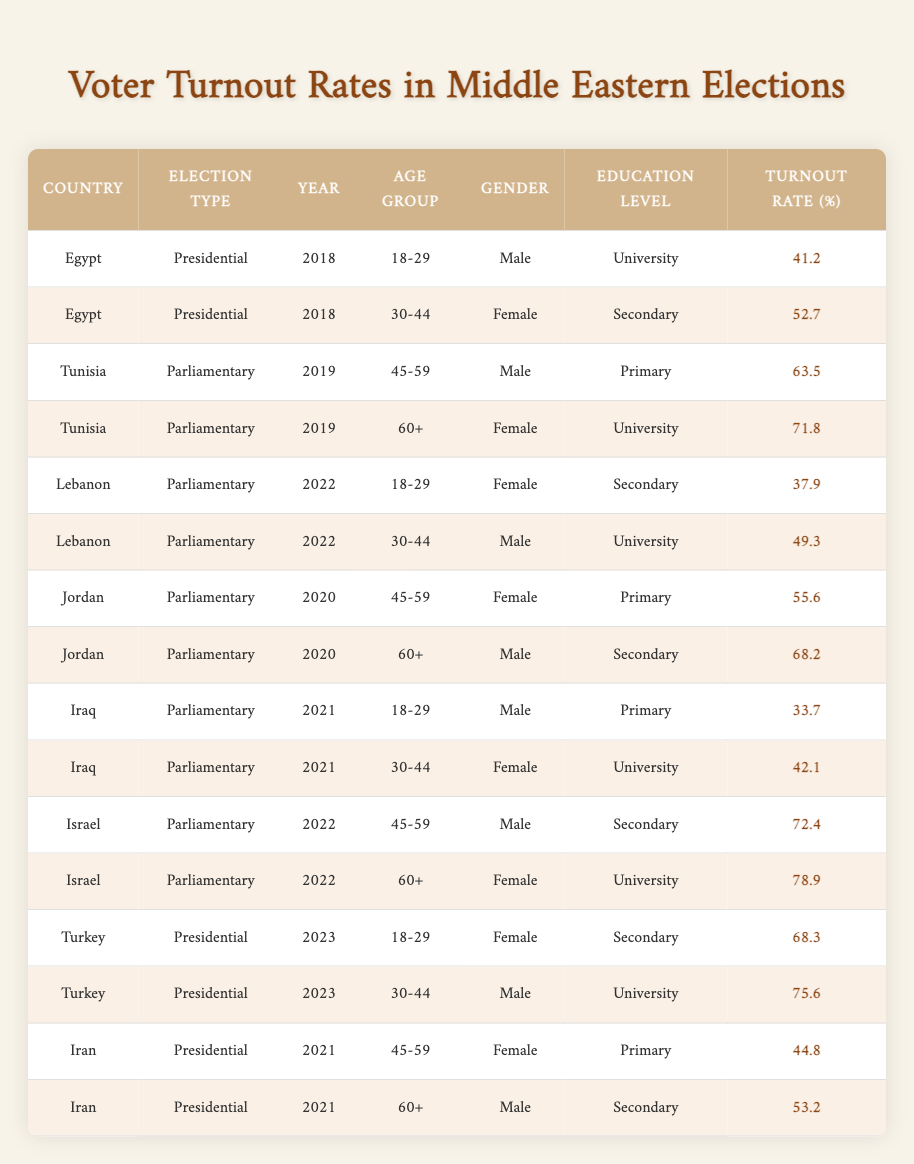What is the highest voter turnout rate reported in the table? By examining the turnout rates in the last column, we can identify that the highest value is 78.9%. It corresponds to the female demographic aged 60+ in Israel during the 2022 parliamentary elections.
Answer: 78.9 What demographic had the lowest voter turnout in Egypt during the 2018 Presidential elections? In the 2018 Presidential elections, the table shows two demographic groups in Egypt: males aged 18-29 with a turnout of 41.2%, and females aged 30-44 with a turnout of 52.7%. Thus, the lowest turnout is for males aged 18-29.
Answer: Males aged 18-29 What was the average voter turnout rate for parliamentary elections across all countries in 2022? The parliamentary elections in 2022 had two records from Lebanon and two from Israel: Lebanon - females aged 18-29 (37.9%) and males aged 30-44 (49.3%); Israel - males aged 45-59 (72.4%) and females aged 60+ (78.9%). Summing these values gives 37.9 + 49.3 + 72.4 + 78.9 = 238.5, and dividing by 4 gives an average turnout of 59.625%.
Answer: 59.63 Is there any instance of a turnout rate below 40% for males aged 18-29? Yes, in the table, we can see that in Iraq for the 2021 parliamentary elections, males aged 18-29 had a turnout rate of 33.7%, which is below 40%.
Answer: Yes Which country had the highest turnout for 30-44 year-old males in presidential elections? Looking specifically at presidential elections, we only see data from Egypt in 2018 and Turkey in 2023. For Egypt (30-44 year-old females), the turnout was 52.7%, whereas Turkey (30-44 year-old males) had a turnout of 75.6%. Thus, Turkey has the higher turnout.
Answer: Turkey What is the difference in voter turnout percentage between the oldest age group (60+) for females in Tunisia and Iran? From Tunisia, the female turnout for 60+ in the 2019 parliamentary elections is 71.8%. From Iran, the female turnout for 60+ in the 2021 presidential elections is 53.2%. The difference is calculated as 71.8 - 53.2 = 18.6%.
Answer: 18.6 What percentage of the total voter turnout rates for females in Iraq (2021) was higher than 40%? The table indicates that females aged 30-44 in Iraq had a turnout of 42.1%, which is higher than 40%. Therefore, out of two female groups (one below 40% and one above), 50% of the total representation falls above this threshold.
Answer: 50% Was the voter turnout for 18-29 year-old females higher in Turkey's 2023 presidential election compared to Lebanon's 2022 parliamentary election? Turkey's 2023 turnout rate for females aged 18-29 is 68.3%, while Lebanon's 2022 turnout for the same group is 37.9%. Comparing these two figures reveals that Turkey's turnout is significantly higher.
Answer: Yes 